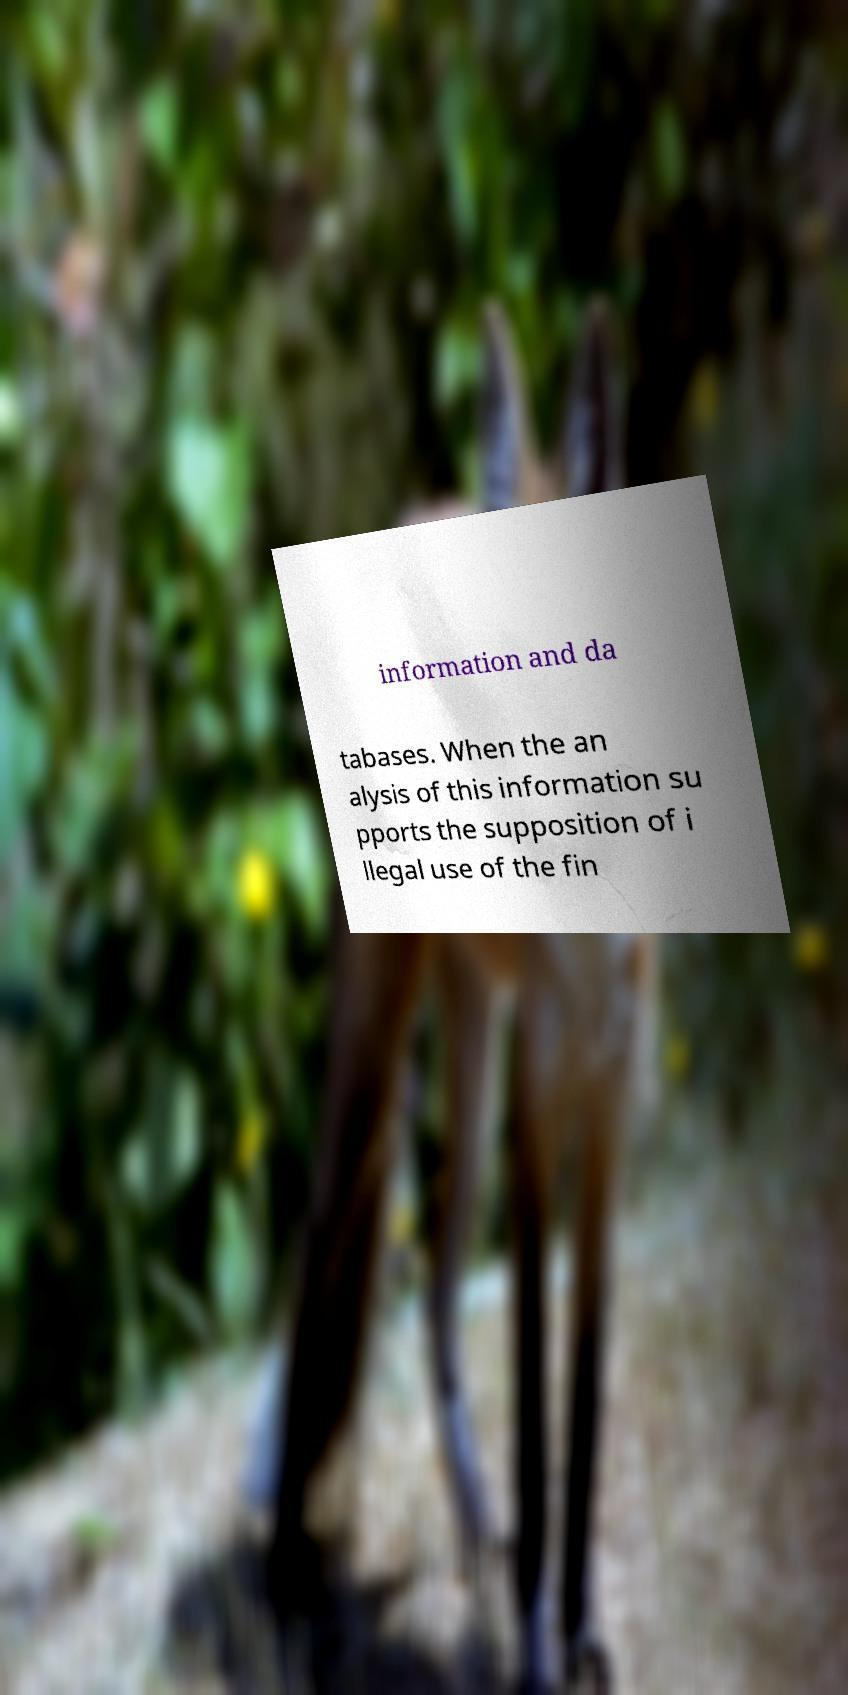Can you accurately transcribe the text from the provided image for me? information and da tabases. When the an alysis of this information su pports the supposition of i llegal use of the fin 